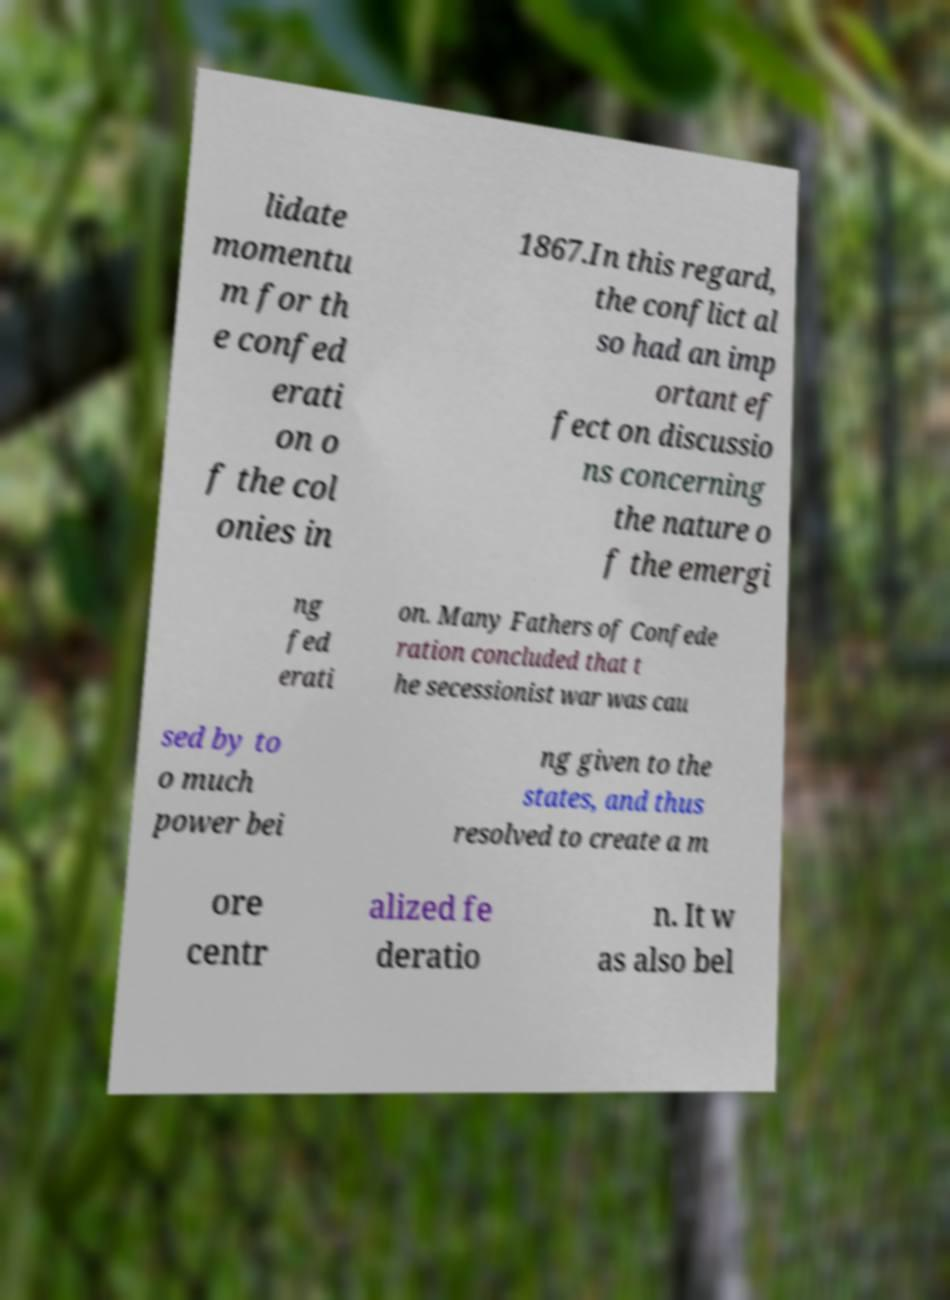Could you assist in decoding the text presented in this image and type it out clearly? lidate momentu m for th e confed erati on o f the col onies in 1867.In this regard, the conflict al so had an imp ortant ef fect on discussio ns concerning the nature o f the emergi ng fed erati on. Many Fathers of Confede ration concluded that t he secessionist war was cau sed by to o much power bei ng given to the states, and thus resolved to create a m ore centr alized fe deratio n. It w as also bel 